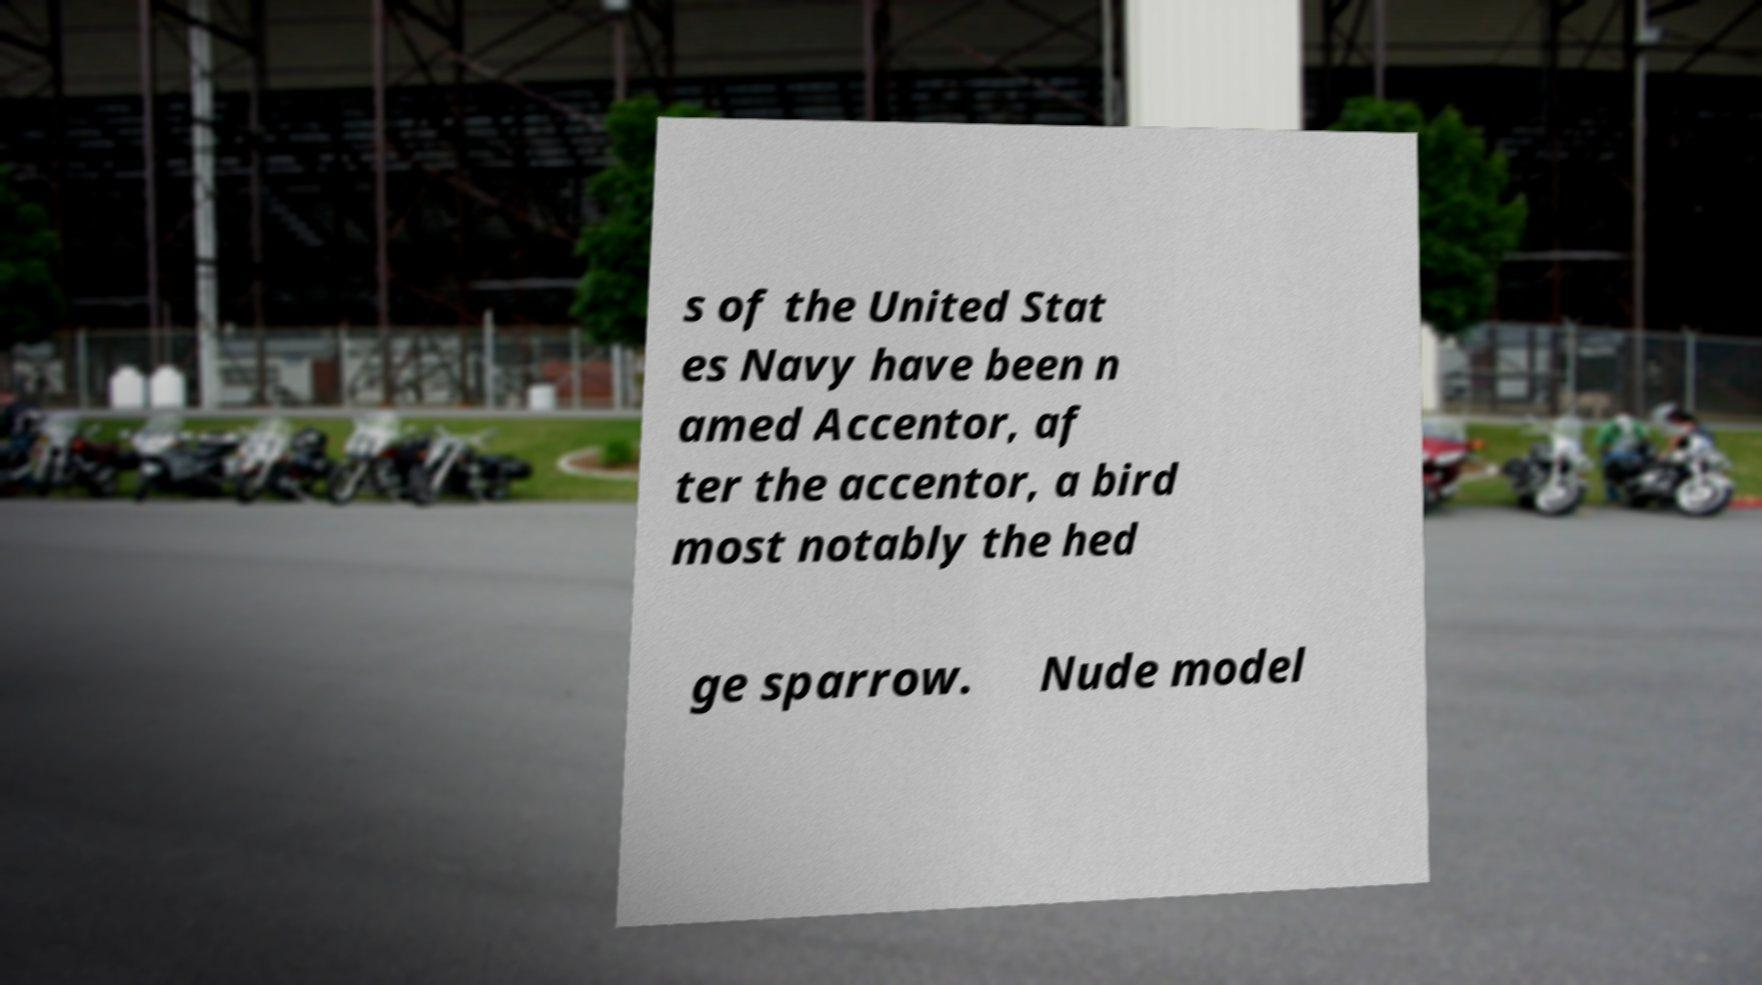Could you extract and type out the text from this image? s of the United Stat es Navy have been n amed Accentor, af ter the accentor, a bird most notably the hed ge sparrow. Nude model 